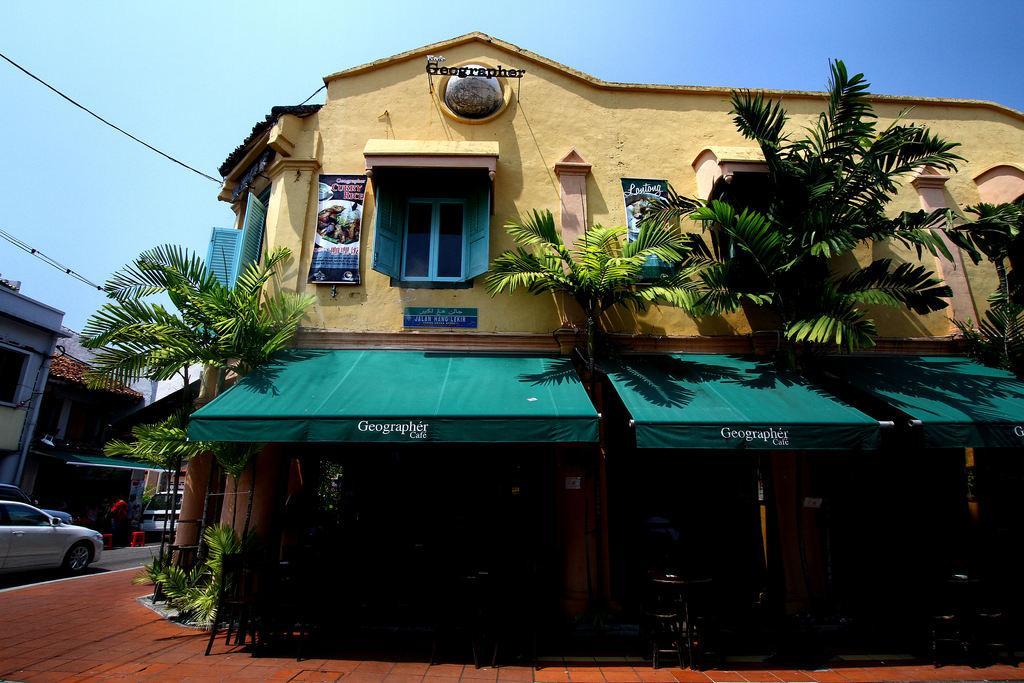How would you summarize this image in a sentence or two? This image consists of a building along with the trees. At the bottom, there is a pavement. On the left, we can see a car on the road. At the top, there is sky. 